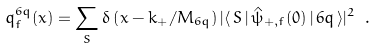<formula> <loc_0><loc_0><loc_500><loc_500>q _ { f } ^ { 6 q } ( x ) = \sum _ { S } \delta \left ( x - k _ { + } / M _ { 6 q } \right ) | \langle \, S \, | \, { \hat { \psi } } _ { + , f } ( 0 ) \, | \, 6 q \, \rangle | ^ { 2 } \ .</formula> 